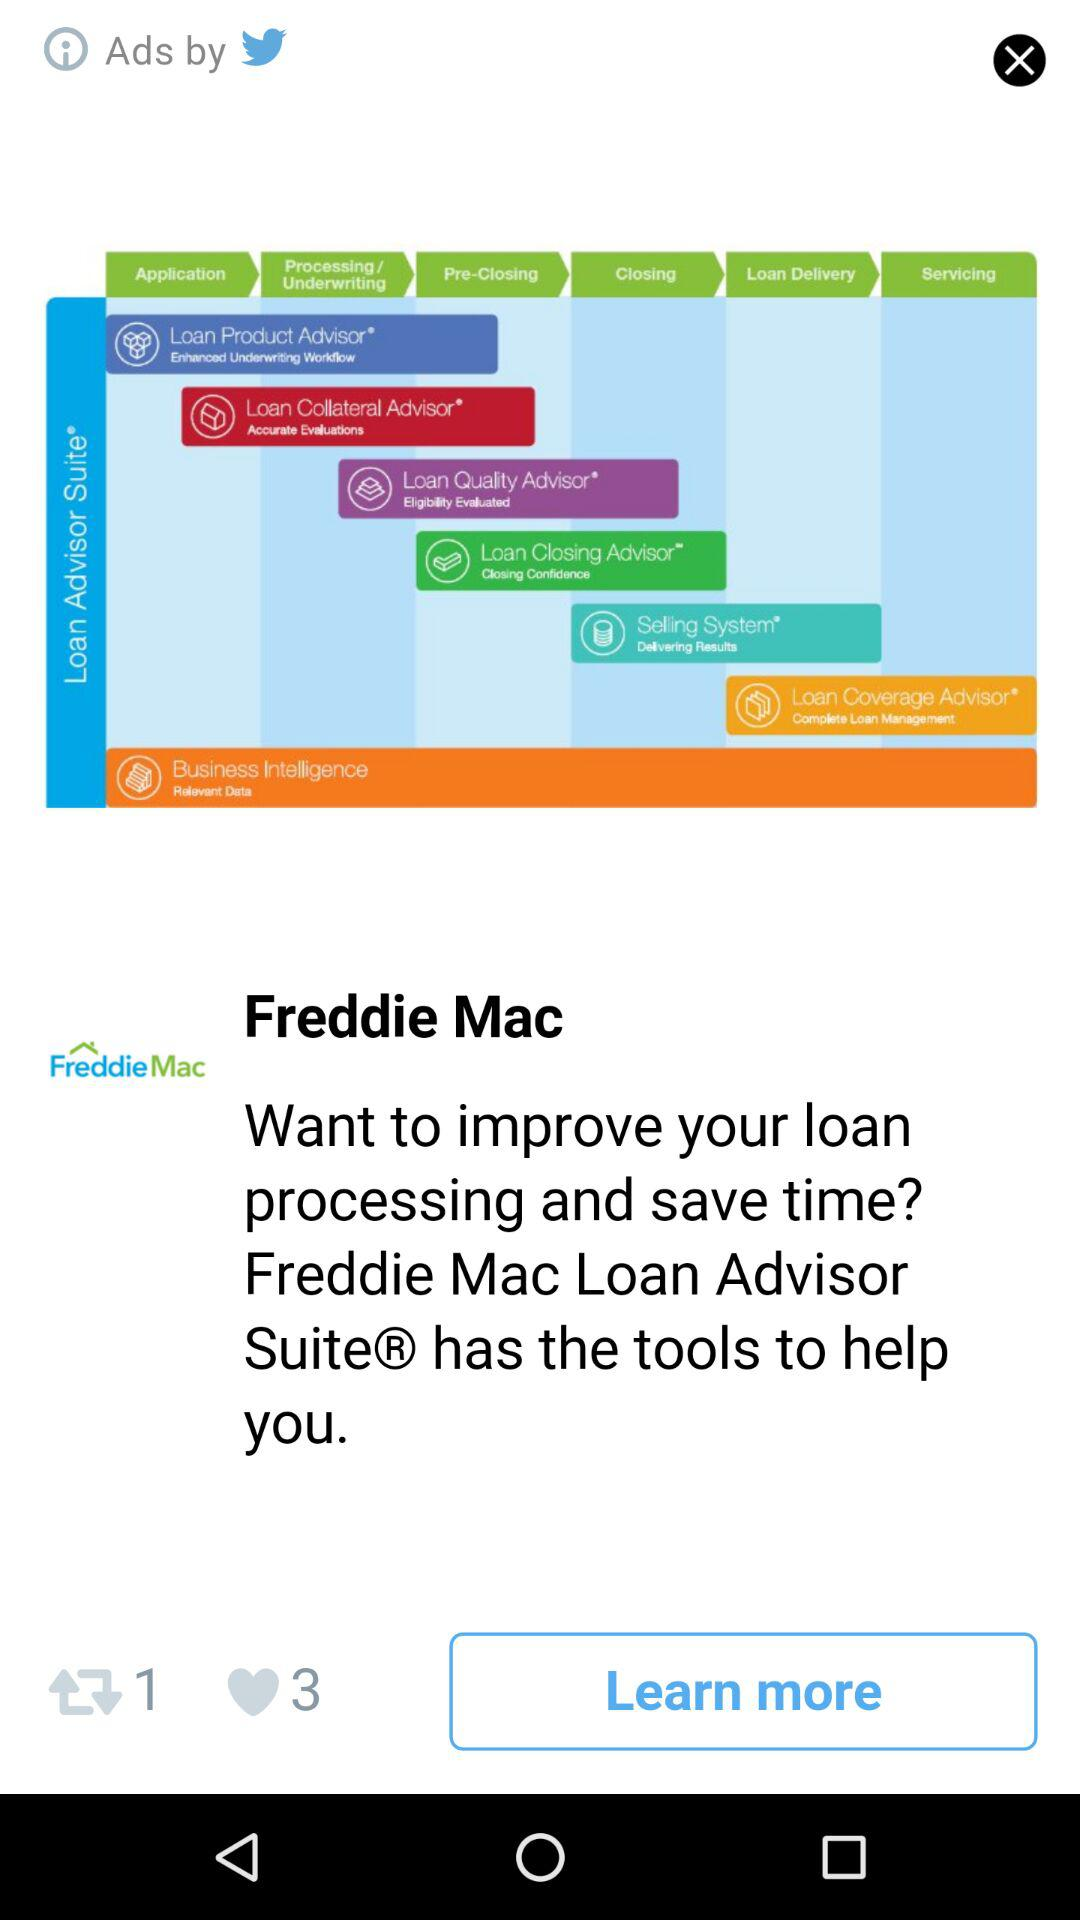How many more hearts than refreshes are there?
Answer the question using a single word or phrase. 2 